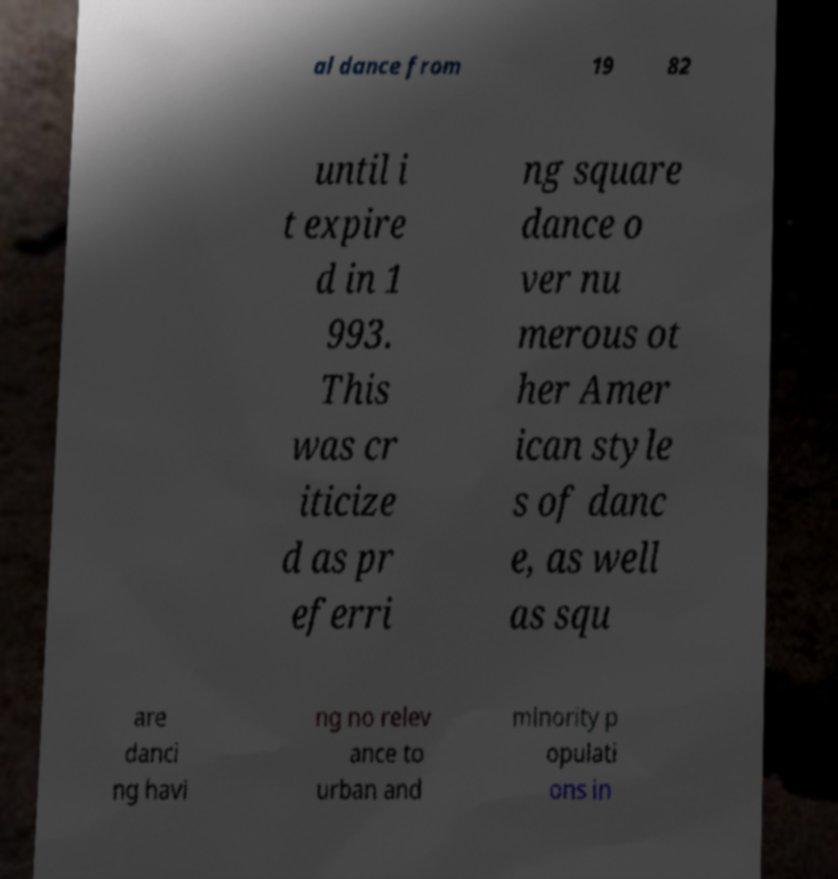There's text embedded in this image that I need extracted. Can you transcribe it verbatim? al dance from 19 82 until i t expire d in 1 993. This was cr iticize d as pr eferri ng square dance o ver nu merous ot her Amer ican style s of danc e, as well as squ are danci ng havi ng no relev ance to urban and minority p opulati ons in 